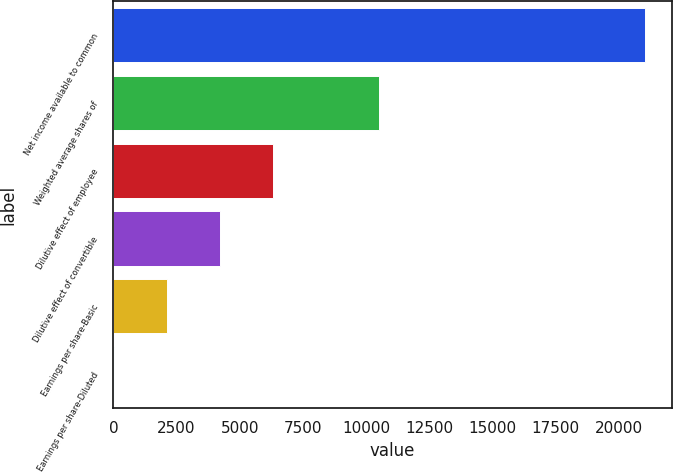Convert chart. <chart><loc_0><loc_0><loc_500><loc_500><bar_chart><fcel>Net income available to common<fcel>Weighted average shares of<fcel>Dilutive effect of employee<fcel>Dilutive effect of convertible<fcel>Earnings per share-Basic<fcel>Earnings per share-Diluted<nl><fcel>21053<fcel>10528.7<fcel>6319.03<fcel>4214.18<fcel>2109.33<fcel>4.48<nl></chart> 